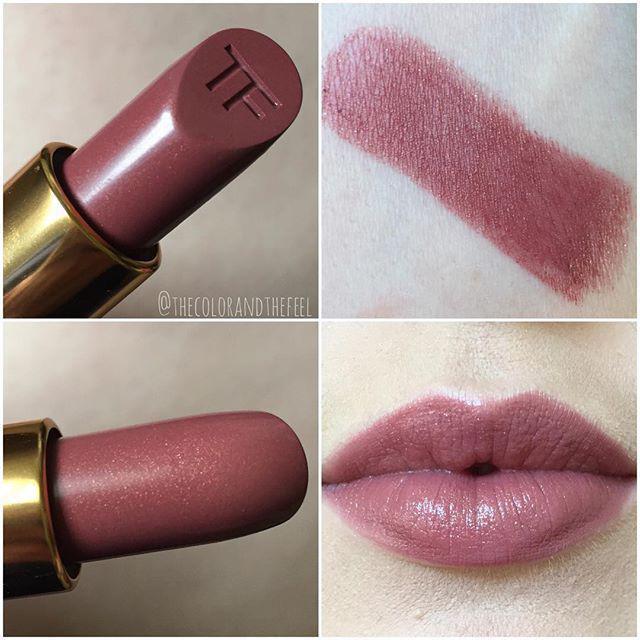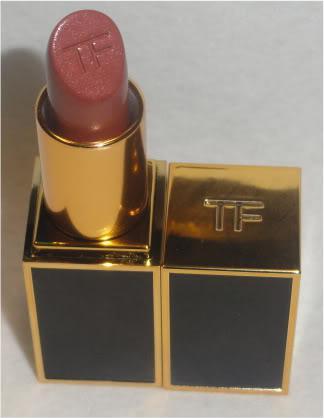The first image is the image on the left, the second image is the image on the right. Examine the images to the left and right. Is the description "There are at least 3 tubes of lipstick in these." accurate? Answer yes or no. Yes. The first image is the image on the left, the second image is the image on the right. Given the left and right images, does the statement "There are multiple lines of lip stick color on an arm." hold true? Answer yes or no. No. 